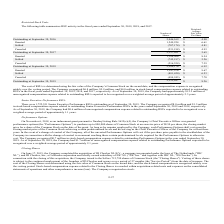According to Mitek Systems's financial document, How is the cost of the Restricted Stock Units (RSUs) determined? using the fair value of the Company’s Common Stock on the award date. The document states: "The cost of RSUs is determined using the fair value of the Company’s Common Stock on the award date, and the compensation expense is recognized..." Also, How much were the stock-based compensation expenses related to outstanding RSUs in fiscal years 2018 and 2019, respectively? The document shows two values: $5.9 million and $6.8 million. From the document: "ly over the vesting period. The Company recognized $6.8 million, $5.9 million, and $4.0 million in stock-based compensation expense related to outstan..." Also, What was the number of shares outstanding on September 30, 2016, and 2017, respectively? The document shows two values: 2,046,169 and 2,357,021. From the document: "Outstanding at September 30, 2016 2,046,169 $ 4.90 Outstanding at September 30, 2017 2,357,021 $ 5.65..." Also, can you calculate: What is the proportion of RSUs that were settled or canceled between 2017 and 2018 over RSUs outstanding on September 30, 2017? To answer this question, I need to perform calculations using the financial data. The calculation is: (745,197+216,554)/2,357,021 , which equals 0.41. This is based on the information: "Canceled (216,554) $ 7.39 Outstanding at September 30, 2017 2,357,021 $ 5.65 Settled (745,197) $ 5.26..." The key data points involved are: 2,357,021, 216,554, 745,197. Also, can you calculate: What is the ratio of the price of RSUs that were granted to the price of RSUs that were settled between 2018 and 2019? To answer this question, I need to perform calculations using the financial data. The calculation is: (1,147,976*9.67)/(881,420*6.53) , which equals 1.93. This is based on the information: "Granted 1,147,976 $ 9.67 Settled (881,420) $ 6.53 Granted 1,147,976 $ 9.67 Settled (881,420) $ 6.53..." The key data points involved are: 1,147,976, 6.53, 881,420. Also, can you calculate: What is the price of RSUs outstanding on September 30, 2019? Based on the calculation: 2,352,487*8.26 , the result is 19431542.62. This is based on the information: "Outstanding at September 30, 2019 2,352,487 $ 8.26 Outstanding at September 30, 2019 2,352,487 $ 8.26..." The key data points involved are: 2,352,487, 8.26. 